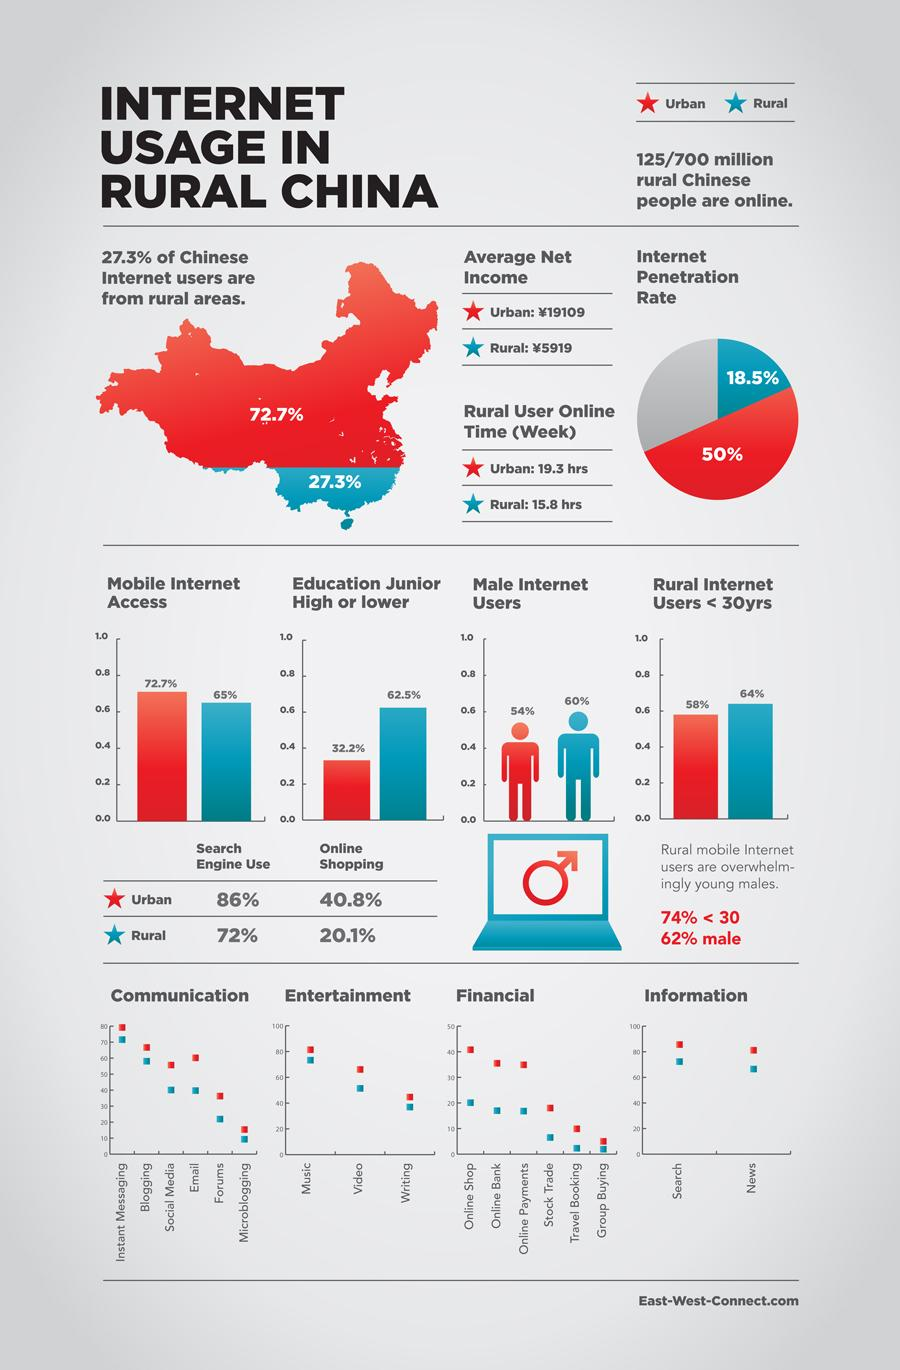Draw attention to some important aspects in this diagram. According to the data, urban users spend more time online than rural users. According to a study on internet usage among male internet users, those from urban regions were found to use the internet more than those from rural regions. In rural China, the internet penetration rate is 18.5%. According to a recent study, 72.7% of internet users in China are from urban areas. This indicates that a large majority of internet users in China live in urban areas, and that internet usage is more prevalent in urban areas than in rural areas. Online shopping is less prevalent in rural areas compared to urban areas. 